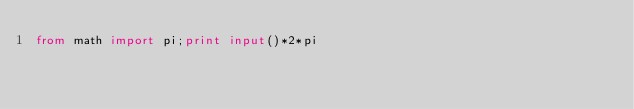<code> <loc_0><loc_0><loc_500><loc_500><_Python_>from math import pi;print input()*2*pi
</code> 